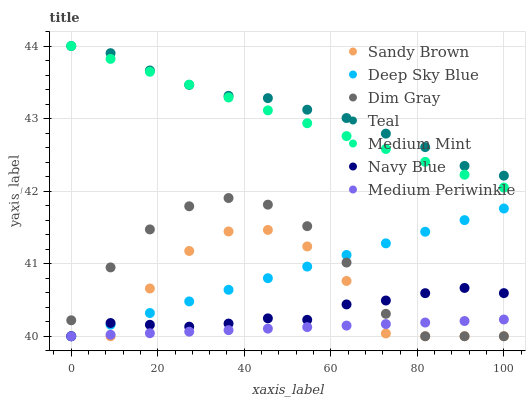Does Medium Periwinkle have the minimum area under the curve?
Answer yes or no. Yes. Does Teal have the maximum area under the curve?
Answer yes or no. Yes. Does Dim Gray have the minimum area under the curve?
Answer yes or no. No. Does Dim Gray have the maximum area under the curve?
Answer yes or no. No. Is Deep Sky Blue the smoothest?
Answer yes or no. Yes. Is Sandy Brown the roughest?
Answer yes or no. Yes. Is Dim Gray the smoothest?
Answer yes or no. No. Is Dim Gray the roughest?
Answer yes or no. No. Does Dim Gray have the lowest value?
Answer yes or no. Yes. Does Teal have the lowest value?
Answer yes or no. No. Does Teal have the highest value?
Answer yes or no. Yes. Does Dim Gray have the highest value?
Answer yes or no. No. Is Medium Periwinkle less than Teal?
Answer yes or no. Yes. Is Teal greater than Sandy Brown?
Answer yes or no. Yes. Does Dim Gray intersect Deep Sky Blue?
Answer yes or no. Yes. Is Dim Gray less than Deep Sky Blue?
Answer yes or no. No. Is Dim Gray greater than Deep Sky Blue?
Answer yes or no. No. Does Medium Periwinkle intersect Teal?
Answer yes or no. No. 